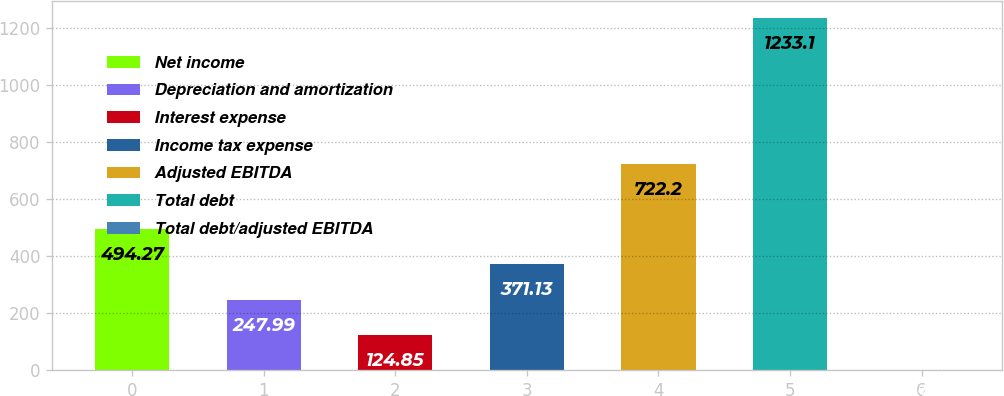<chart> <loc_0><loc_0><loc_500><loc_500><bar_chart><fcel>Net income<fcel>Depreciation and amortization<fcel>Interest expense<fcel>Income tax expense<fcel>Adjusted EBITDA<fcel>Total debt<fcel>Total debt/adjusted EBITDA<nl><fcel>494.27<fcel>247.99<fcel>124.85<fcel>371.13<fcel>722.2<fcel>1233.1<fcel>1.71<nl></chart> 